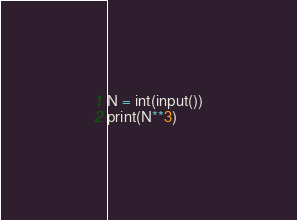<code> <loc_0><loc_0><loc_500><loc_500><_Python_>N = int(input())
print(N**3)</code> 